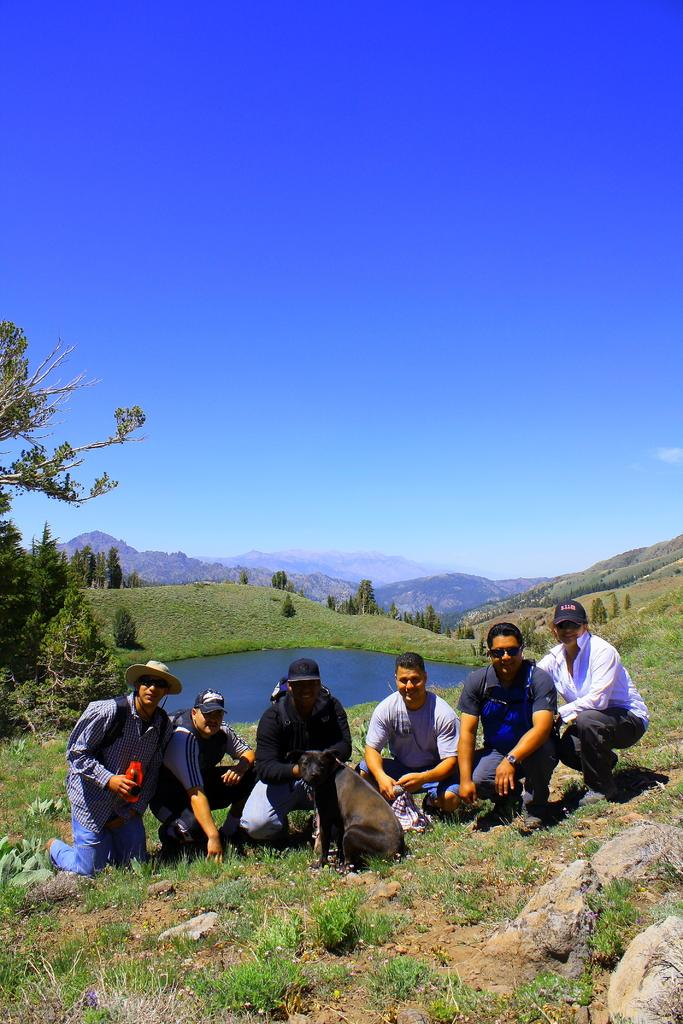How many individuals are in the image? There are six people in the image. What other living creature is present in the image? A dog is present in the image. What are the people and dog doing in the image? The people and dog are posing for a photo. What can be seen in the background of the image? There is a lake, a tree, and a clear sky in the background of the image. How many babies are being held by the people in the image? There are no babies present in the image; only six people and a dog are visible. What type of stocking is being worn by the farmer in the image? There is no farmer or stocking present in the image. 